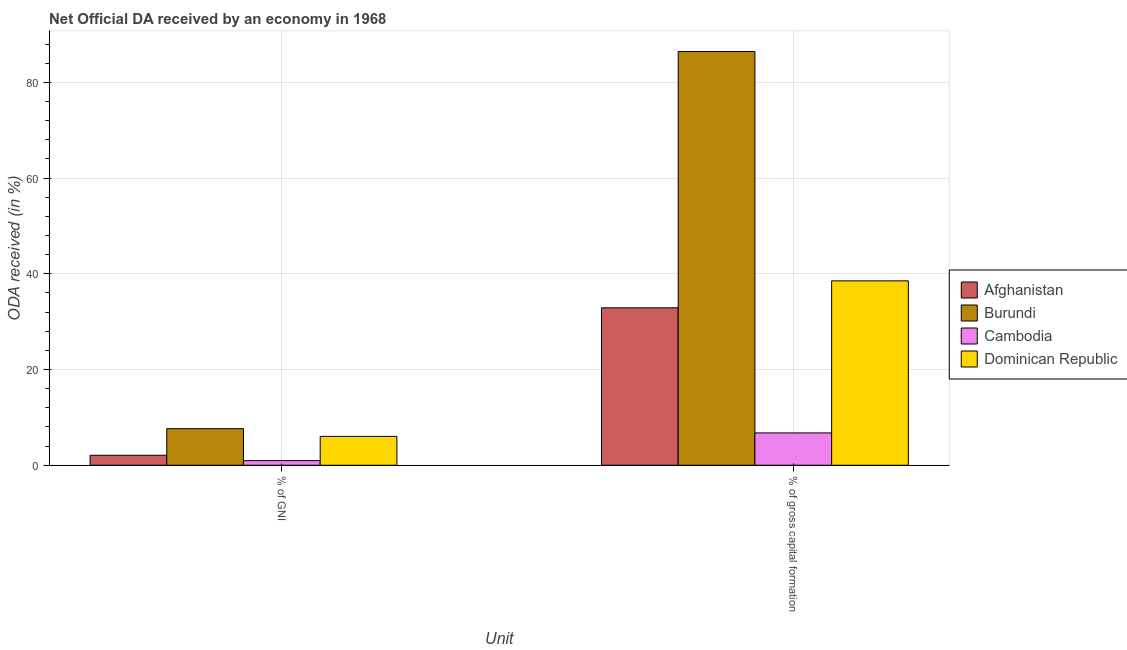How many groups of bars are there?
Ensure brevity in your answer.  2. Are the number of bars on each tick of the X-axis equal?
Make the answer very short. Yes. How many bars are there on the 2nd tick from the left?
Your response must be concise. 4. How many bars are there on the 2nd tick from the right?
Offer a terse response. 4. What is the label of the 2nd group of bars from the left?
Your response must be concise. % of gross capital formation. What is the oda received as percentage of gni in Burundi?
Your answer should be compact. 7.64. Across all countries, what is the maximum oda received as percentage of gni?
Ensure brevity in your answer.  7.64. Across all countries, what is the minimum oda received as percentage of gni?
Offer a very short reply. 0.96. In which country was the oda received as percentage of gni maximum?
Keep it short and to the point. Burundi. In which country was the oda received as percentage of gross capital formation minimum?
Give a very brief answer. Cambodia. What is the total oda received as percentage of gni in the graph?
Your response must be concise. 16.72. What is the difference between the oda received as percentage of gross capital formation in Dominican Republic and that in Cambodia?
Provide a short and direct response. 31.77. What is the difference between the oda received as percentage of gni in Dominican Republic and the oda received as percentage of gross capital formation in Afghanistan?
Your answer should be very brief. -26.87. What is the average oda received as percentage of gni per country?
Ensure brevity in your answer.  4.18. What is the difference between the oda received as percentage of gross capital formation and oda received as percentage of gni in Cambodia?
Provide a short and direct response. 5.79. What is the ratio of the oda received as percentage of gross capital formation in Dominican Republic to that in Burundi?
Provide a succinct answer. 0.45. Is the oda received as percentage of gross capital formation in Burundi less than that in Dominican Republic?
Your answer should be compact. No. In how many countries, is the oda received as percentage of gni greater than the average oda received as percentage of gni taken over all countries?
Your answer should be very brief. 2. What does the 4th bar from the left in % of gross capital formation represents?
Your answer should be compact. Dominican Republic. What does the 1st bar from the right in % of gross capital formation represents?
Give a very brief answer. Dominican Republic. How many bars are there?
Your answer should be compact. 8. How many countries are there in the graph?
Keep it short and to the point. 4. What is the difference between two consecutive major ticks on the Y-axis?
Your response must be concise. 20. Are the values on the major ticks of Y-axis written in scientific E-notation?
Make the answer very short. No. Does the graph contain any zero values?
Make the answer very short. No. Does the graph contain grids?
Offer a very short reply. Yes. How many legend labels are there?
Offer a terse response. 4. How are the legend labels stacked?
Give a very brief answer. Vertical. What is the title of the graph?
Offer a very short reply. Net Official DA received by an economy in 1968. Does "Europe(all income levels)" appear as one of the legend labels in the graph?
Your answer should be very brief. No. What is the label or title of the X-axis?
Offer a terse response. Unit. What is the label or title of the Y-axis?
Your answer should be compact. ODA received (in %). What is the ODA received (in %) of Afghanistan in % of GNI?
Offer a terse response. 2.09. What is the ODA received (in %) of Burundi in % of GNI?
Keep it short and to the point. 7.64. What is the ODA received (in %) in Cambodia in % of GNI?
Your answer should be compact. 0.96. What is the ODA received (in %) in Dominican Republic in % of GNI?
Ensure brevity in your answer.  6.03. What is the ODA received (in %) in Afghanistan in % of gross capital formation?
Provide a succinct answer. 32.9. What is the ODA received (in %) in Burundi in % of gross capital formation?
Offer a very short reply. 86.45. What is the ODA received (in %) of Cambodia in % of gross capital formation?
Your answer should be very brief. 6.76. What is the ODA received (in %) of Dominican Republic in % of gross capital formation?
Provide a succinct answer. 38.52. Across all Unit, what is the maximum ODA received (in %) in Afghanistan?
Ensure brevity in your answer.  32.9. Across all Unit, what is the maximum ODA received (in %) in Burundi?
Offer a terse response. 86.45. Across all Unit, what is the maximum ODA received (in %) in Cambodia?
Your answer should be compact. 6.76. Across all Unit, what is the maximum ODA received (in %) in Dominican Republic?
Provide a succinct answer. 38.52. Across all Unit, what is the minimum ODA received (in %) in Afghanistan?
Offer a very short reply. 2.09. Across all Unit, what is the minimum ODA received (in %) of Burundi?
Give a very brief answer. 7.64. Across all Unit, what is the minimum ODA received (in %) of Cambodia?
Offer a terse response. 0.96. Across all Unit, what is the minimum ODA received (in %) in Dominican Republic?
Provide a succinct answer. 6.03. What is the total ODA received (in %) of Afghanistan in the graph?
Your answer should be compact. 34.98. What is the total ODA received (in %) in Burundi in the graph?
Your answer should be very brief. 94.09. What is the total ODA received (in %) in Cambodia in the graph?
Your answer should be compact. 7.72. What is the total ODA received (in %) of Dominican Republic in the graph?
Offer a terse response. 44.55. What is the difference between the ODA received (in %) of Afghanistan in % of GNI and that in % of gross capital formation?
Ensure brevity in your answer.  -30.81. What is the difference between the ODA received (in %) in Burundi in % of GNI and that in % of gross capital formation?
Offer a terse response. -78.8. What is the difference between the ODA received (in %) in Cambodia in % of GNI and that in % of gross capital formation?
Your answer should be compact. -5.79. What is the difference between the ODA received (in %) in Dominican Republic in % of GNI and that in % of gross capital formation?
Your response must be concise. -32.5. What is the difference between the ODA received (in %) in Afghanistan in % of GNI and the ODA received (in %) in Burundi in % of gross capital formation?
Your response must be concise. -84.36. What is the difference between the ODA received (in %) of Afghanistan in % of GNI and the ODA received (in %) of Cambodia in % of gross capital formation?
Provide a short and direct response. -4.67. What is the difference between the ODA received (in %) of Afghanistan in % of GNI and the ODA received (in %) of Dominican Republic in % of gross capital formation?
Offer a very short reply. -36.44. What is the difference between the ODA received (in %) in Burundi in % of GNI and the ODA received (in %) in Cambodia in % of gross capital formation?
Offer a terse response. 0.89. What is the difference between the ODA received (in %) of Burundi in % of GNI and the ODA received (in %) of Dominican Republic in % of gross capital formation?
Give a very brief answer. -30.88. What is the difference between the ODA received (in %) in Cambodia in % of GNI and the ODA received (in %) in Dominican Republic in % of gross capital formation?
Offer a terse response. -37.56. What is the average ODA received (in %) in Afghanistan per Unit?
Provide a short and direct response. 17.49. What is the average ODA received (in %) of Burundi per Unit?
Give a very brief answer. 47.05. What is the average ODA received (in %) in Cambodia per Unit?
Ensure brevity in your answer.  3.86. What is the average ODA received (in %) of Dominican Republic per Unit?
Offer a terse response. 22.28. What is the difference between the ODA received (in %) of Afghanistan and ODA received (in %) of Burundi in % of GNI?
Offer a terse response. -5.56. What is the difference between the ODA received (in %) in Afghanistan and ODA received (in %) in Cambodia in % of GNI?
Keep it short and to the point. 1.12. What is the difference between the ODA received (in %) in Afghanistan and ODA received (in %) in Dominican Republic in % of GNI?
Provide a succinct answer. -3.94. What is the difference between the ODA received (in %) in Burundi and ODA received (in %) in Cambodia in % of GNI?
Provide a succinct answer. 6.68. What is the difference between the ODA received (in %) in Burundi and ODA received (in %) in Dominican Republic in % of GNI?
Offer a very short reply. 1.62. What is the difference between the ODA received (in %) of Cambodia and ODA received (in %) of Dominican Republic in % of GNI?
Provide a short and direct response. -5.07. What is the difference between the ODA received (in %) in Afghanistan and ODA received (in %) in Burundi in % of gross capital formation?
Your response must be concise. -53.55. What is the difference between the ODA received (in %) in Afghanistan and ODA received (in %) in Cambodia in % of gross capital formation?
Offer a terse response. 26.14. What is the difference between the ODA received (in %) in Afghanistan and ODA received (in %) in Dominican Republic in % of gross capital formation?
Keep it short and to the point. -5.63. What is the difference between the ODA received (in %) of Burundi and ODA received (in %) of Cambodia in % of gross capital formation?
Provide a short and direct response. 79.69. What is the difference between the ODA received (in %) in Burundi and ODA received (in %) in Dominican Republic in % of gross capital formation?
Your answer should be compact. 47.92. What is the difference between the ODA received (in %) of Cambodia and ODA received (in %) of Dominican Republic in % of gross capital formation?
Ensure brevity in your answer.  -31.77. What is the ratio of the ODA received (in %) in Afghanistan in % of GNI to that in % of gross capital formation?
Provide a succinct answer. 0.06. What is the ratio of the ODA received (in %) of Burundi in % of GNI to that in % of gross capital formation?
Provide a succinct answer. 0.09. What is the ratio of the ODA received (in %) of Cambodia in % of GNI to that in % of gross capital formation?
Make the answer very short. 0.14. What is the ratio of the ODA received (in %) in Dominican Republic in % of GNI to that in % of gross capital formation?
Your answer should be very brief. 0.16. What is the difference between the highest and the second highest ODA received (in %) in Afghanistan?
Provide a succinct answer. 30.81. What is the difference between the highest and the second highest ODA received (in %) in Burundi?
Give a very brief answer. 78.8. What is the difference between the highest and the second highest ODA received (in %) in Cambodia?
Make the answer very short. 5.79. What is the difference between the highest and the second highest ODA received (in %) of Dominican Republic?
Offer a terse response. 32.5. What is the difference between the highest and the lowest ODA received (in %) in Afghanistan?
Keep it short and to the point. 30.81. What is the difference between the highest and the lowest ODA received (in %) in Burundi?
Give a very brief answer. 78.8. What is the difference between the highest and the lowest ODA received (in %) of Cambodia?
Give a very brief answer. 5.79. What is the difference between the highest and the lowest ODA received (in %) of Dominican Republic?
Offer a terse response. 32.5. 